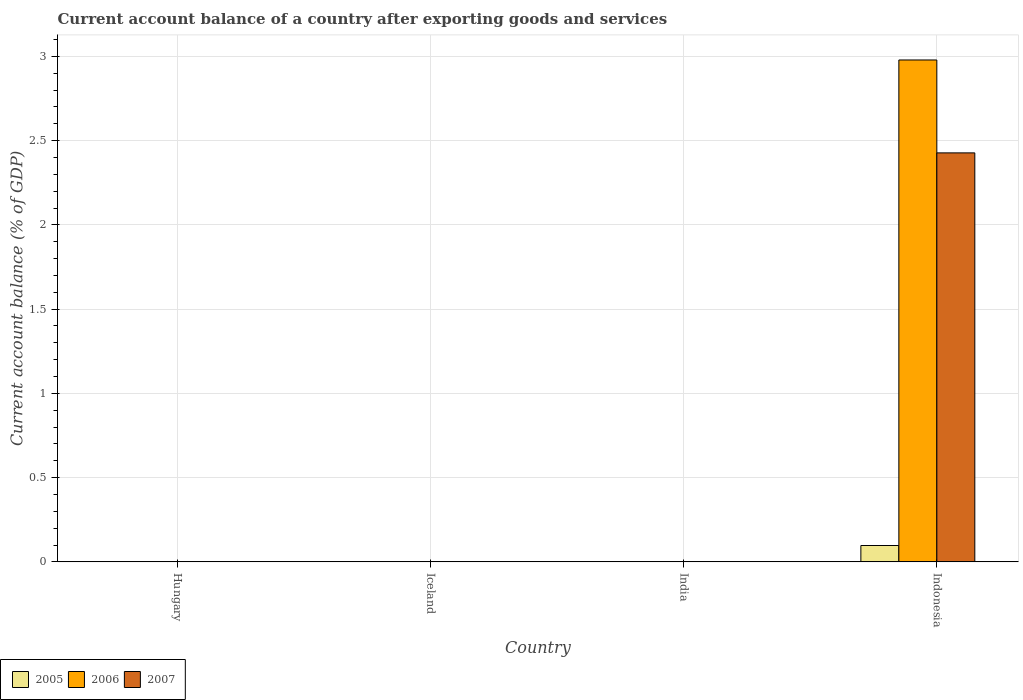Are the number of bars per tick equal to the number of legend labels?
Your answer should be compact. No. Are the number of bars on each tick of the X-axis equal?
Make the answer very short. No. How many bars are there on the 2nd tick from the right?
Ensure brevity in your answer.  0. What is the label of the 4th group of bars from the left?
Keep it short and to the point. Indonesia. In how many cases, is the number of bars for a given country not equal to the number of legend labels?
Give a very brief answer. 3. What is the account balance in 2007 in Hungary?
Your response must be concise. 0. Across all countries, what is the maximum account balance in 2005?
Keep it short and to the point. 0.1. What is the total account balance in 2007 in the graph?
Offer a very short reply. 2.43. What is the difference between the account balance in 2007 in Hungary and the account balance in 2006 in Indonesia?
Your response must be concise. -2.98. What is the average account balance in 2007 per country?
Your response must be concise. 0.61. What is the difference between the account balance of/in 2005 and account balance of/in 2007 in Indonesia?
Make the answer very short. -2.33. What is the difference between the highest and the lowest account balance in 2006?
Provide a succinct answer. 2.98. Is it the case that in every country, the sum of the account balance in 2005 and account balance in 2007 is greater than the account balance in 2006?
Your response must be concise. No. How many bars are there?
Provide a short and direct response. 3. What is the difference between two consecutive major ticks on the Y-axis?
Make the answer very short. 0.5. Does the graph contain grids?
Your answer should be very brief. Yes. Where does the legend appear in the graph?
Provide a succinct answer. Bottom left. How are the legend labels stacked?
Offer a very short reply. Horizontal. What is the title of the graph?
Your answer should be very brief. Current account balance of a country after exporting goods and services. What is the label or title of the X-axis?
Provide a succinct answer. Country. What is the label or title of the Y-axis?
Provide a short and direct response. Current account balance (% of GDP). What is the Current account balance (% of GDP) in 2005 in Hungary?
Make the answer very short. 0. What is the Current account balance (% of GDP) of 2007 in Hungary?
Provide a short and direct response. 0. What is the Current account balance (% of GDP) of 2007 in Iceland?
Provide a succinct answer. 0. What is the Current account balance (% of GDP) of 2007 in India?
Ensure brevity in your answer.  0. What is the Current account balance (% of GDP) of 2005 in Indonesia?
Make the answer very short. 0.1. What is the Current account balance (% of GDP) of 2006 in Indonesia?
Keep it short and to the point. 2.98. What is the Current account balance (% of GDP) in 2007 in Indonesia?
Your response must be concise. 2.43. Across all countries, what is the maximum Current account balance (% of GDP) of 2005?
Offer a very short reply. 0.1. Across all countries, what is the maximum Current account balance (% of GDP) in 2006?
Your response must be concise. 2.98. Across all countries, what is the maximum Current account balance (% of GDP) in 2007?
Give a very brief answer. 2.43. What is the total Current account balance (% of GDP) of 2005 in the graph?
Offer a terse response. 0.1. What is the total Current account balance (% of GDP) in 2006 in the graph?
Your response must be concise. 2.98. What is the total Current account balance (% of GDP) of 2007 in the graph?
Keep it short and to the point. 2.43. What is the average Current account balance (% of GDP) of 2005 per country?
Your answer should be very brief. 0.02. What is the average Current account balance (% of GDP) of 2006 per country?
Offer a terse response. 0.74. What is the average Current account balance (% of GDP) in 2007 per country?
Your answer should be compact. 0.61. What is the difference between the Current account balance (% of GDP) in 2005 and Current account balance (% of GDP) in 2006 in Indonesia?
Keep it short and to the point. -2.88. What is the difference between the Current account balance (% of GDP) in 2005 and Current account balance (% of GDP) in 2007 in Indonesia?
Make the answer very short. -2.33. What is the difference between the Current account balance (% of GDP) in 2006 and Current account balance (% of GDP) in 2007 in Indonesia?
Offer a very short reply. 0.55. What is the difference between the highest and the lowest Current account balance (% of GDP) of 2005?
Provide a succinct answer. 0.1. What is the difference between the highest and the lowest Current account balance (% of GDP) of 2006?
Provide a short and direct response. 2.98. What is the difference between the highest and the lowest Current account balance (% of GDP) of 2007?
Make the answer very short. 2.43. 